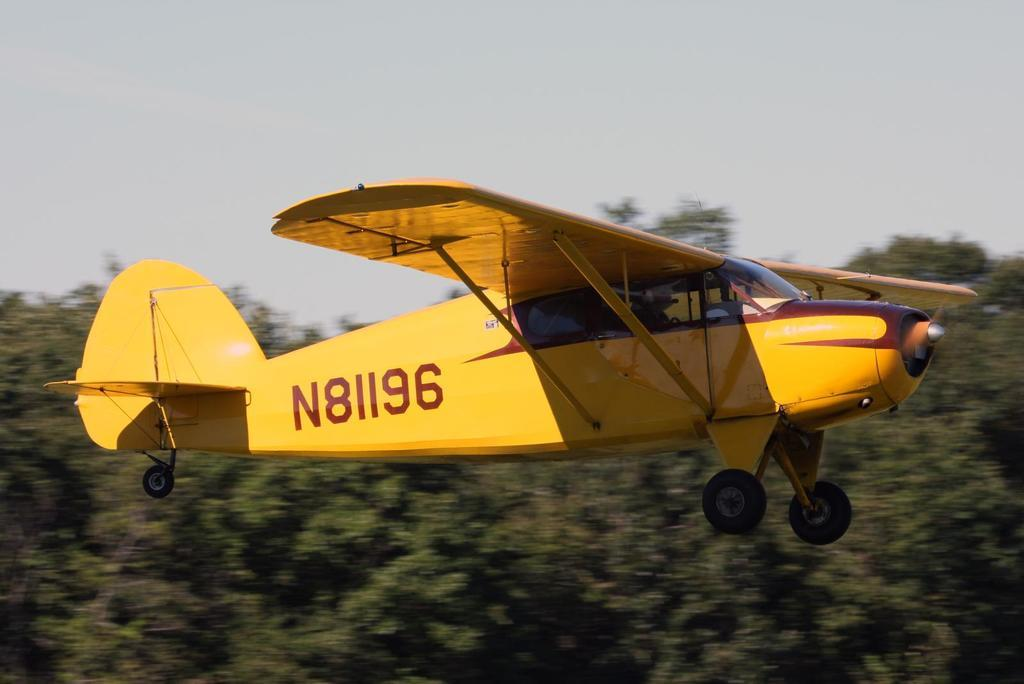What is the main subject of the image? The main subject of the image is an aircraft flying. What can be seen in the background of the image? There are trees visible in the image. What else is visible in the image besides the aircraft and trees? The sky is visible in the image. What type of beef is being served at the doctor's invention in the image? There is no doctor or invention present in the image, and no beef is mentioned or visible. 